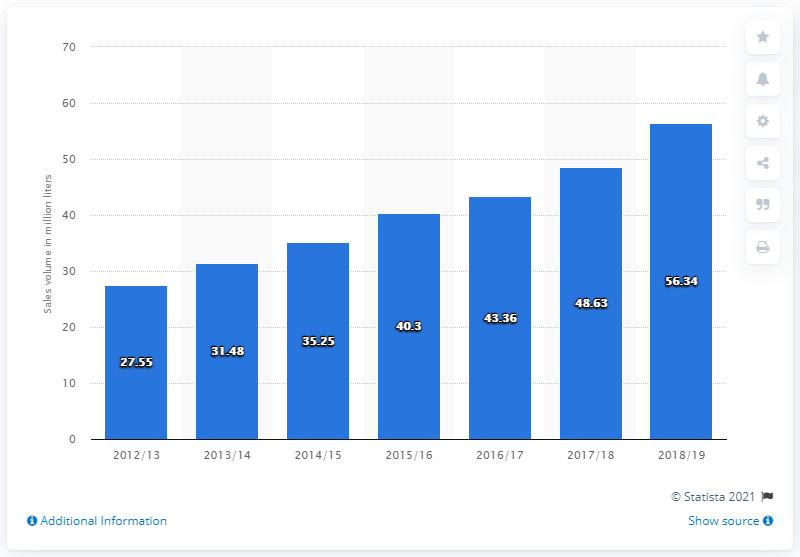Indicate a few pertinent items in this graphic. The sales volume of refreshments in British Columbia during the fiscal year ending March 2019 was 56.34. 